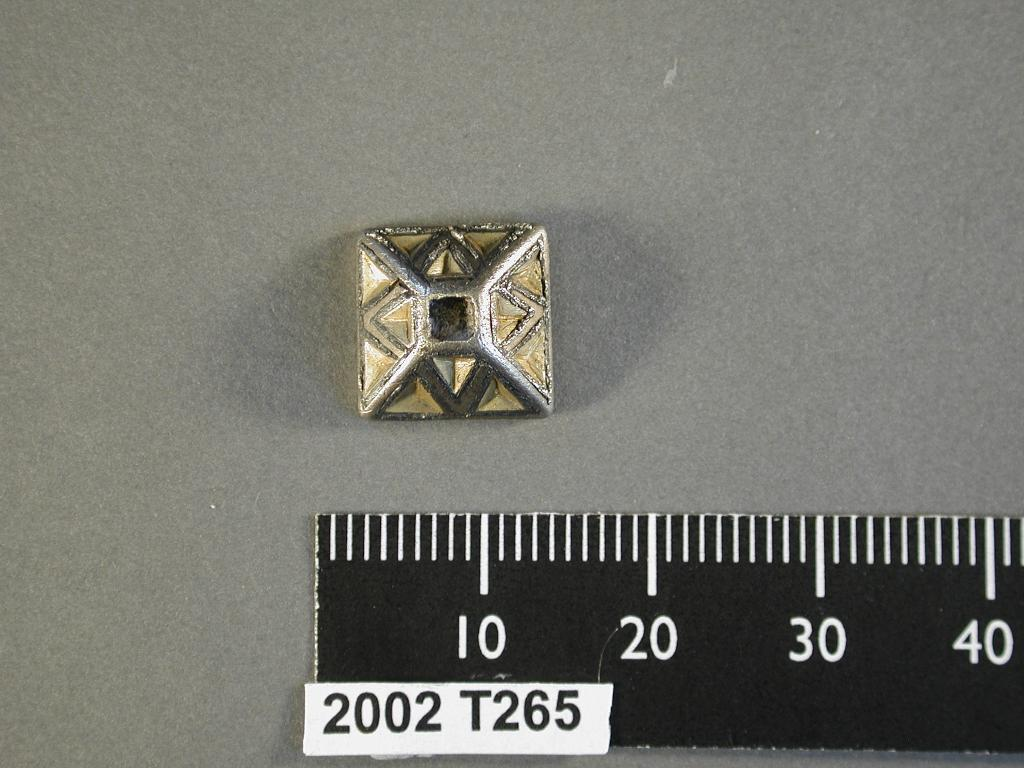<image>
Relay a brief, clear account of the picture shown. A 2002 T265 rule is measuring a square object. 